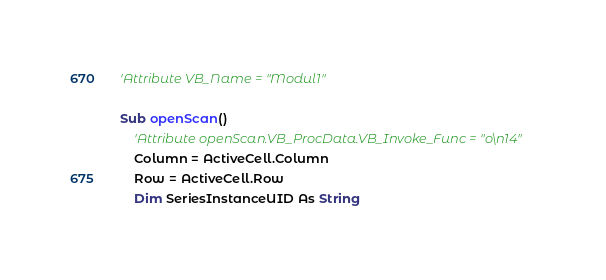Convert code to text. <code><loc_0><loc_0><loc_500><loc_500><_VisualBasic_>'Attribute VB_Name = "Modul1"

Sub openScan()
    'Attribute openScan.VB_ProcData.VB_Invoke_Func = "o\n14"
    Column = ActiveCell.Column
    Row = ActiveCell.Row
    Dim SeriesInstanceUID As String</code> 